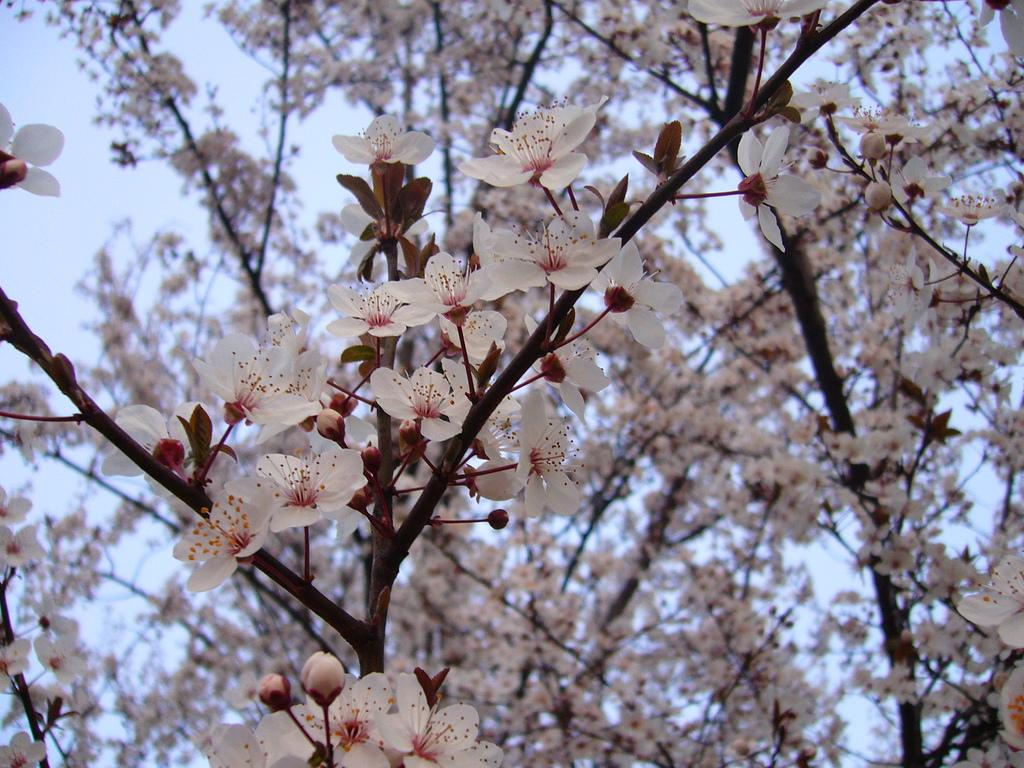What type of vegetation is on the tree in the image? There are flowers on the tree in the image. What can be seen in the background of the image? The sky is visible in the background of the image. What type of hat is the current wearing in the image? There is no current or hat present in the image. 